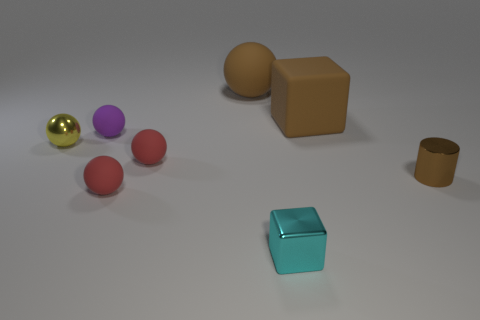Subtract 1 balls. How many balls are left? 4 Subtract all yellow spheres. How many spheres are left? 4 Subtract all big matte spheres. How many spheres are left? 4 Subtract all blue spheres. Subtract all green cylinders. How many spheres are left? 5 Add 1 brown metal things. How many objects exist? 9 Subtract all blocks. How many objects are left? 6 Subtract all large gray metallic spheres. Subtract all red rubber spheres. How many objects are left? 6 Add 2 metallic cubes. How many metallic cubes are left? 3 Add 7 red matte cylinders. How many red matte cylinders exist? 7 Subtract 0 blue blocks. How many objects are left? 8 